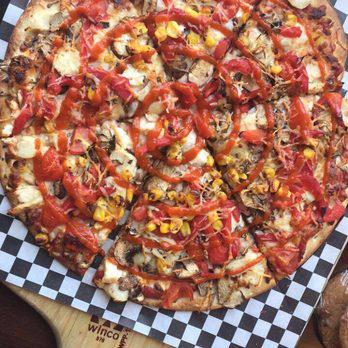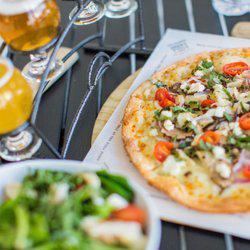The first image is the image on the left, the second image is the image on the right. Examine the images to the left and right. Is the description "In the image on the right, the pizza is placed next to a salad." accurate? Answer yes or no. Yes. The first image is the image on the left, the second image is the image on the right. Examine the images to the left and right. Is the description "At least one of the drinks is in a paper cup." accurate? Answer yes or no. No. 